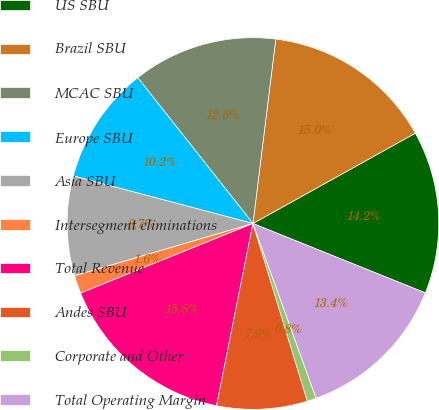Convert chart. <chart><loc_0><loc_0><loc_500><loc_500><pie_chart><fcel>US SBU<fcel>Brazil SBU<fcel>MCAC SBU<fcel>Europe SBU<fcel>Asia SBU<fcel>Intersegment eliminations<fcel>Total Revenue<fcel>Andes SBU<fcel>Corporate and Other<fcel>Total Operating Margin<nl><fcel>14.17%<fcel>14.96%<fcel>12.6%<fcel>10.24%<fcel>8.66%<fcel>1.57%<fcel>15.75%<fcel>7.87%<fcel>0.79%<fcel>13.39%<nl></chart> 